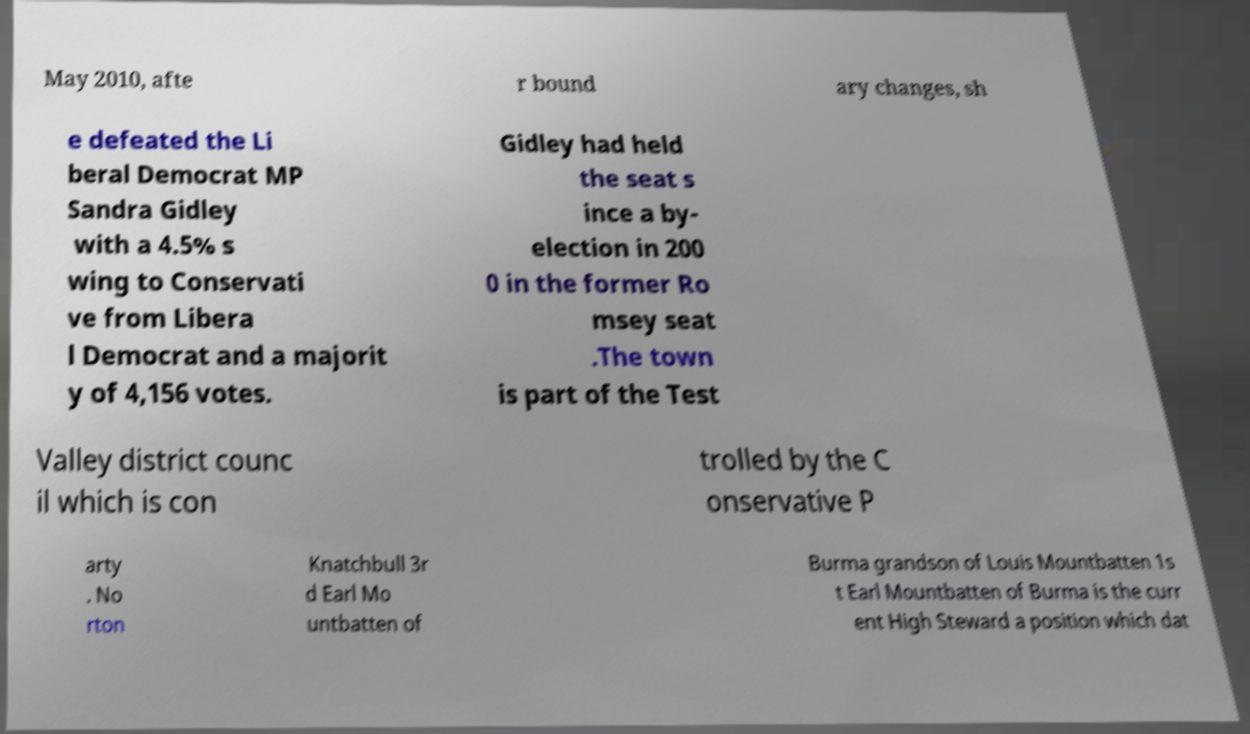Please read and relay the text visible in this image. What does it say? May 2010, afte r bound ary changes, sh e defeated the Li beral Democrat MP Sandra Gidley with a 4.5% s wing to Conservati ve from Libera l Democrat and a majorit y of 4,156 votes. Gidley had held the seat s ince a by- election in 200 0 in the former Ro msey seat .The town is part of the Test Valley district counc il which is con trolled by the C onservative P arty . No rton Knatchbull 3r d Earl Mo untbatten of Burma grandson of Louis Mountbatten 1s t Earl Mountbatten of Burma is the curr ent High Steward a position which dat 